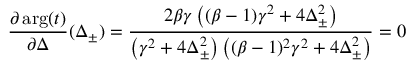<formula> <loc_0><loc_0><loc_500><loc_500>\frac { \partial \arg ( t ) } { \partial \Delta } ( \Delta _ { \pm } ) = \frac { 2 \beta \gamma \left ( ( \beta - 1 ) \gamma ^ { 2 } + 4 \Delta _ { \pm } ^ { 2 } \right ) } { \left ( \gamma ^ { 2 } + 4 \Delta _ { \pm } ^ { 2 } \right ) \left ( ( \beta - 1 ) ^ { 2 } \gamma ^ { 2 } + 4 \Delta _ { \pm } ^ { 2 } \right ) } = 0</formula> 